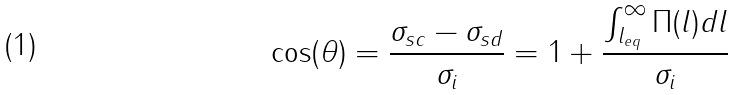Convert formula to latex. <formula><loc_0><loc_0><loc_500><loc_500>\cos ( \theta ) = \frac { \sigma _ { s c } - \sigma _ { s d } } { \sigma _ { i } } = 1 + \frac { \int _ { l _ { e q } } ^ { \infty } \Pi ( l ) d l } { \sigma _ { i } }</formula> 